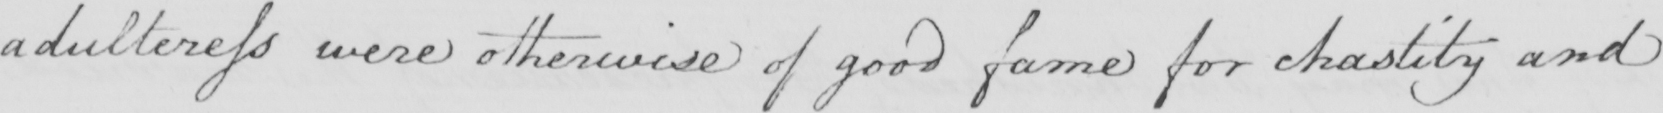What is written in this line of handwriting? adulteress were otherwise of good fame for chastity and 